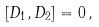<formula> <loc_0><loc_0><loc_500><loc_500>[ D _ { 1 } , D _ { 2 } ] = 0 \, ,</formula> 